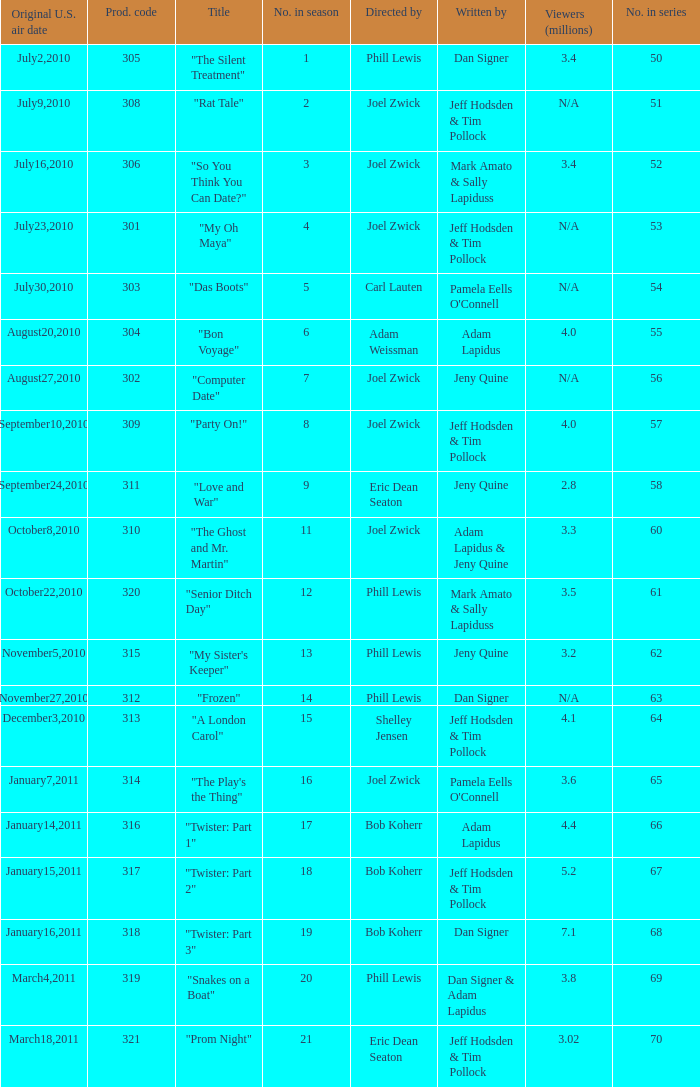How many million viewers watched episode 6? 4.0. 